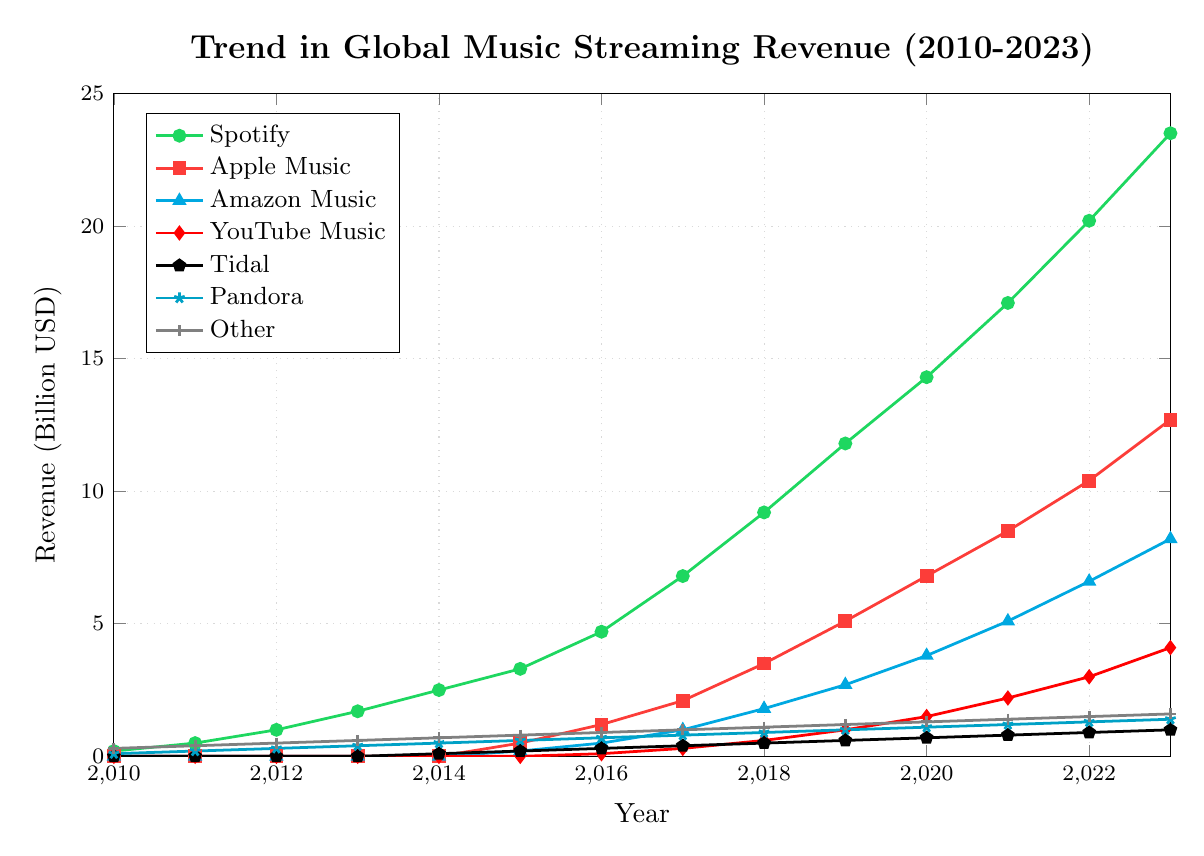Which platform showed the highest growth in revenue from 2010 to 2023? To find the highest growth, we examine the difference in revenue between 2023 and 2010 for each platform. Spotify's revenue increased from 0.2 billion to 23.5 billion, which is the largest increase among all platforms.
Answer: Spotify In which year did Apple Music first appear in the revenue data? By looking at the chart, we see that Apple Music's revenue starts being non-zero in the year 2015.
Answer: 2015 How does the revenue of YouTube Music in 2023 compare to Pandora's revenue in 2023? YouTube Music's revenue in 2023 is 4.1 billion, while Pandora's revenue in 2023 is 1.4 billion. Thus, YouTube Music's revenue is higher.
Answer: YouTube Music's revenue is higher What is the average annual growth in revenue for Spotify from 2010 to 2023? Spotify’s growth can be calculated by taking the revenue in 2023 (23.5 billion) and subtracting the revenue in 2010 (0.2 billion), then dividing by the number of years (2023 - 2010 = 13). So, (23.5 - 0.2) / 13 ≈ 1.8 billion per year.
Answer: ≈ 1.8 billion per year Between 2017 and 2023, which platform had the steepest increase in revenue? To determine the steepest increase between 2017 and 2023, we subtract the 2017 revenue from 2023 revenue for each platform and compare the differences. Spotify increased from 6.8 billion to 23.5 billion, which is a difference of 16.7 billion—the largest among all platforms.
Answer: Spotify Which platform had the smallest total revenue increase from 2010 to 2023? By comparing the revenue increase for all platforms from 2010 to 2023, Tidal increased from 0 to 1.0 billion, which is the smallest increase.
Answer: Tidal In what year did Amazon Music's revenue reach over 1 billion USD? By examining the chart, Amazon Music's revenue exceeded 1 billion for the first time in 2017.
Answer: 2017 Calculate the sum of revenues for all platforms in 2023. To find the total, we sum the revenues for all platforms in 2023: 23.5 (Spotify) + 12.7 (Apple Music) + 8.2 (Amazon Music) + 4.1 (YouTube Music) + 1.0 (Tidal) + 1.4 (Pandora) + 1.6 (Other) = 52.5 billion.
Answer: 52.5 billion Which year marks the first appearance of Tidal in the revenue data, and what was the initial revenue? Tidal first appears in the revenue data in 2014 with a revenue of 0.1 billion.
Answer: 2014, 0.1 billion Compare the growth rates of Spotify and Apple Music from 2015 to 2023. Spotify’s revenue went from 3.3 billion in 2015 to 23.5 billion in 2023, an increase of 20.2 billion. Apple Music’s revenue went from 0.5 billion in 2015 to 12.7 billion in 2023, an increase of 12.2 billion. Thus, Spotify had a higher growth rate.
Answer: Spotify had a higher growth rate 